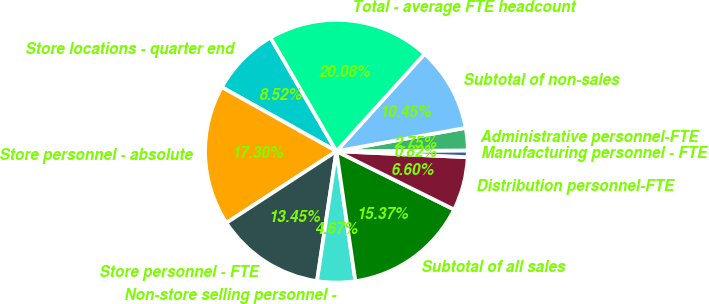Convert chart to OTSL. <chart><loc_0><loc_0><loc_500><loc_500><pie_chart><fcel>Store locations - quarter end<fcel>Store personnel - absolute<fcel>Store personnel - FTE<fcel>Non-store selling personnel -<fcel>Subtotal of all sales<fcel>Distribution personnel-FTE<fcel>Manufacturing personnel - FTE<fcel>Administrative personnel-FTE<fcel>Subtotal of non-sales<fcel>Total - average FTE headcount<nl><fcel>8.52%<fcel>17.3%<fcel>13.45%<fcel>4.67%<fcel>15.37%<fcel>6.6%<fcel>0.82%<fcel>2.75%<fcel>10.45%<fcel>20.08%<nl></chart> 